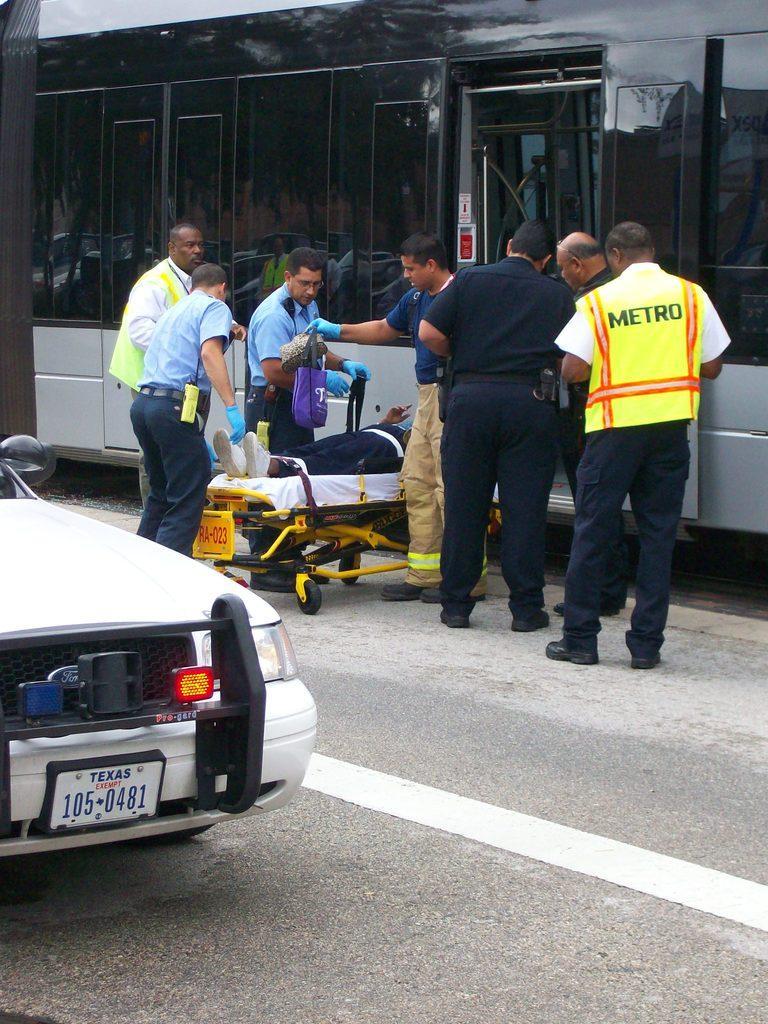Please provide a concise description of this image. There are group of people standing. I can see a person laying on a stretcher. This looks like a vehicle with the doors. On the left side of the image, I can see a car on the road. This looks like a pole. I can see a person holding a bag. 